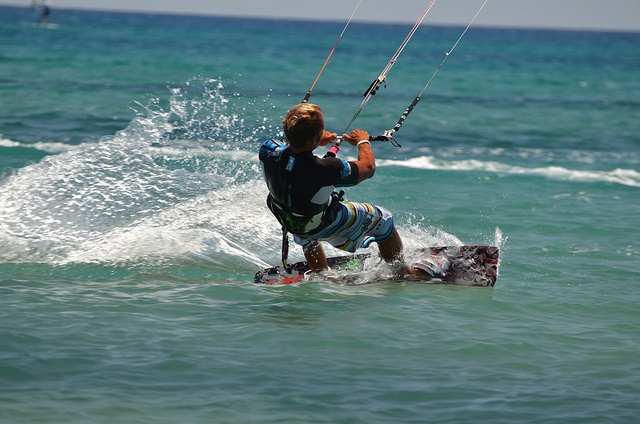Describe the objects in this image and their specific colors. I can see people in darkgray, black, gray, and blue tones, surfboard in darkgray, gray, black, and maroon tones, surfboard in darkgray, teal, and gray tones, and people in darkgray, blue, darkblue, and gray tones in this image. 